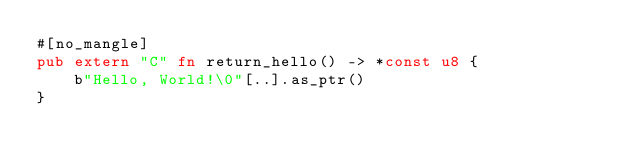Convert code to text. <code><loc_0><loc_0><loc_500><loc_500><_Rust_>#[no_mangle]
pub extern "C" fn return_hello() -> *const u8 {
    b"Hello, World!\0"[..].as_ptr()
}
</code> 